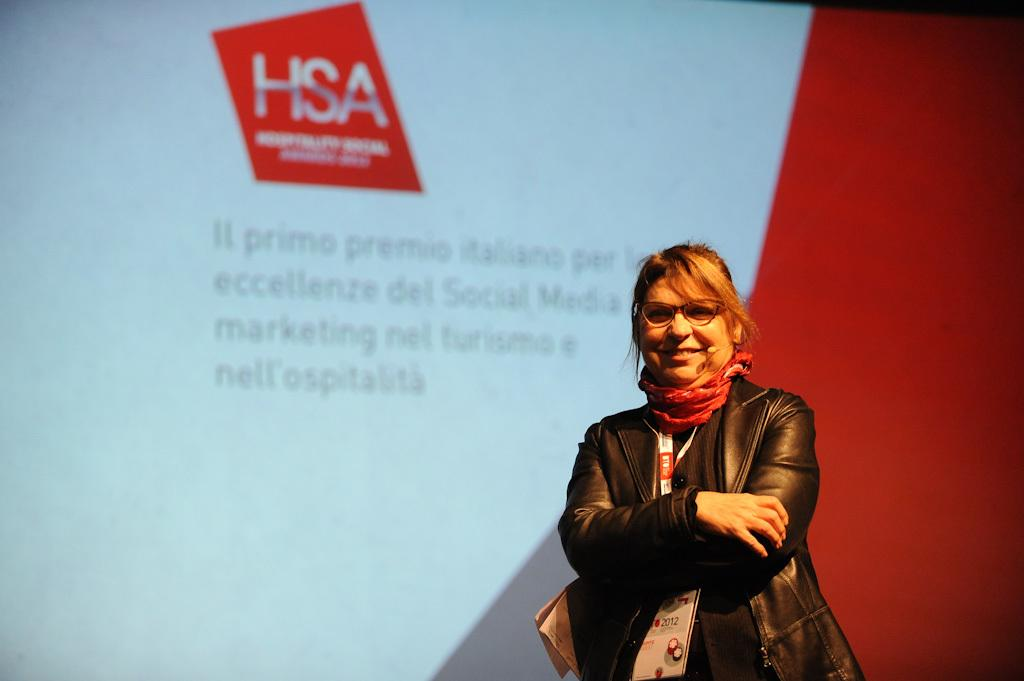Who or what is present in the image? There is a person in the image. What is the person doing or expressing? The person is smiling. What can be seen behind the person? There is a screen visible behind the person. What type of stove is being used by the beginner in the image? There is no stove or beginner present in the image; it only features a person smiling in front of a screen. 